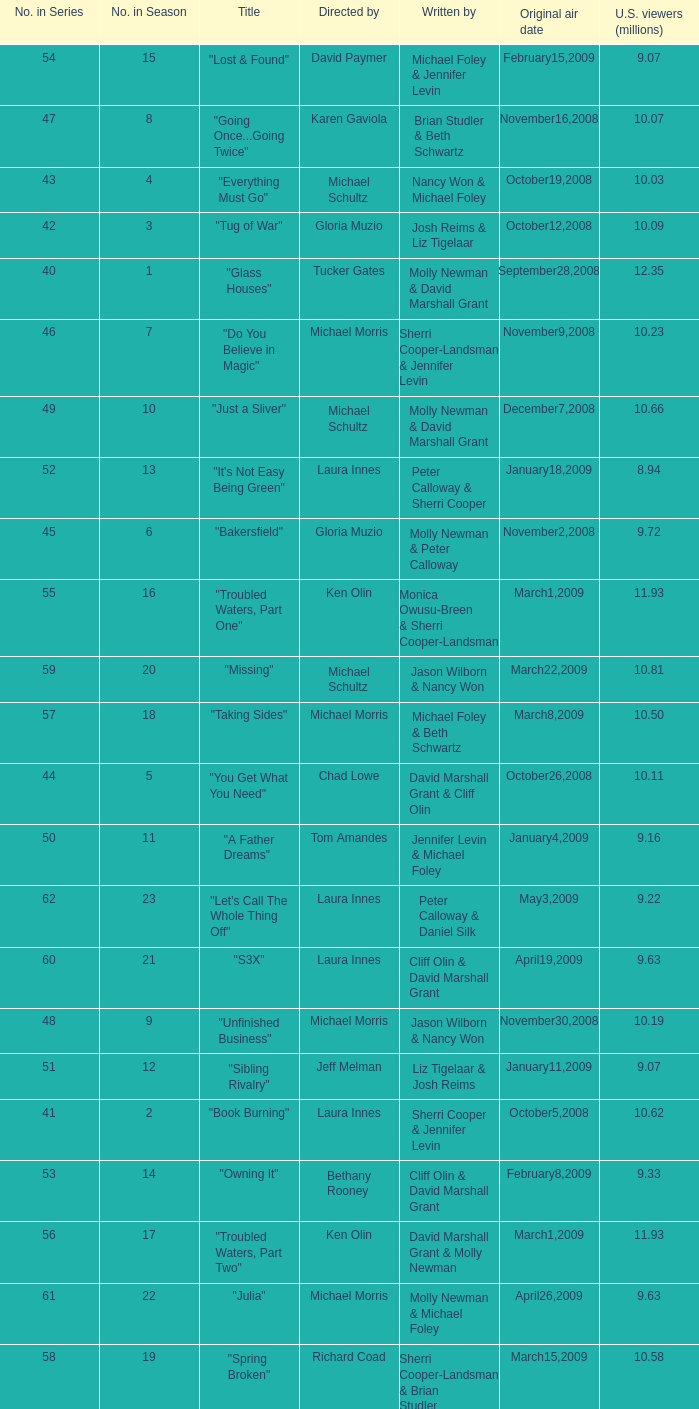When did the episode titled "Do you believe in magic" run for the first time? November9,2008. 